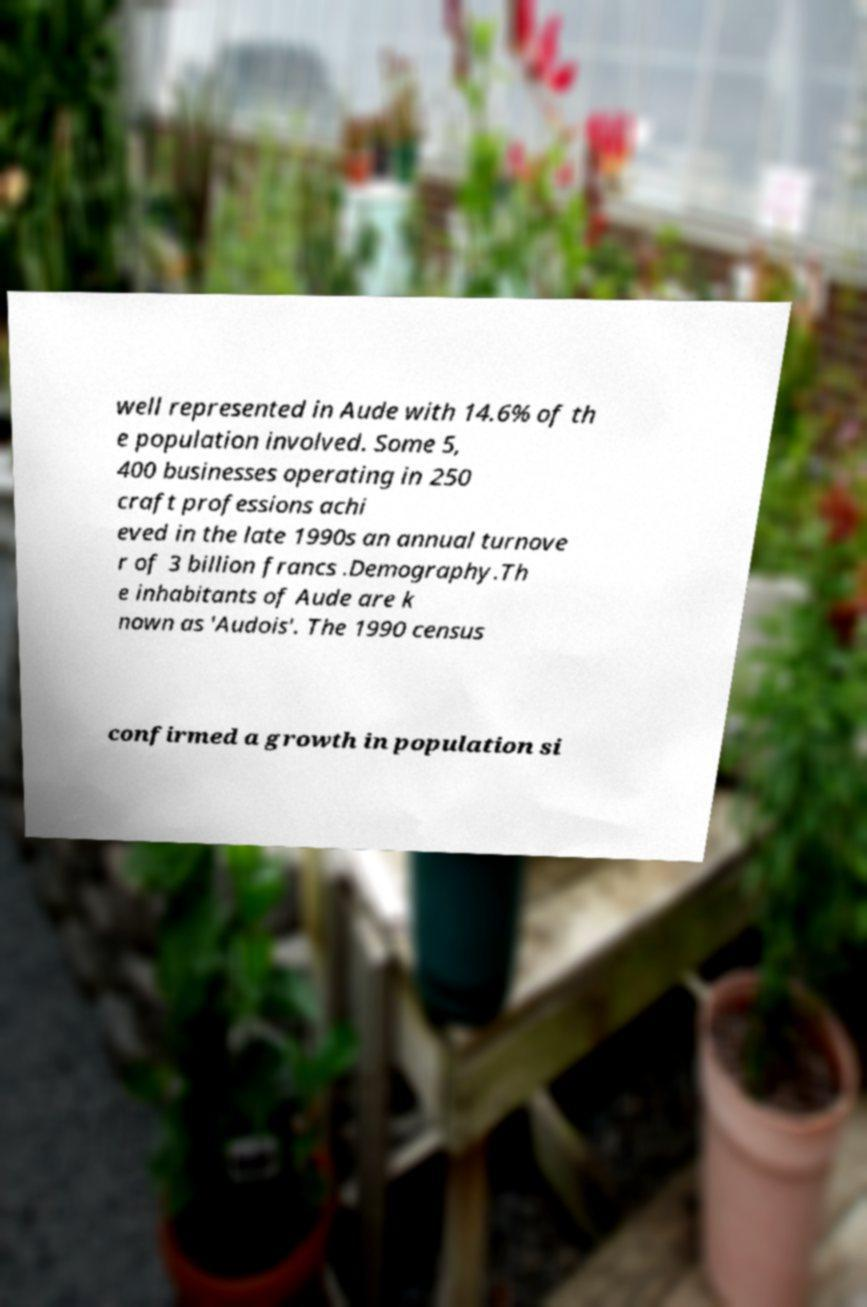Please read and relay the text visible in this image. What does it say? well represented in Aude with 14.6% of th e population involved. Some 5, 400 businesses operating in 250 craft professions achi eved in the late 1990s an annual turnove r of 3 billion francs .Demography.Th e inhabitants of Aude are k nown as 'Audois'. The 1990 census confirmed a growth in population si 